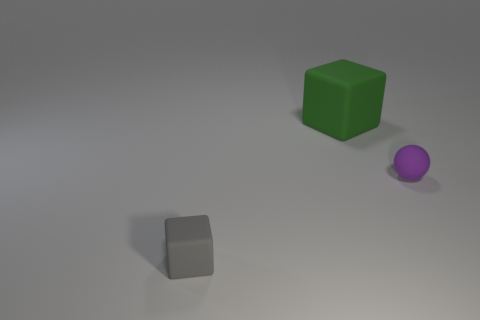Add 1 green objects. How many objects exist? 4 Subtract all spheres. How many objects are left? 2 Subtract all tiny purple rubber objects. Subtract all tiny cyan rubber balls. How many objects are left? 2 Add 3 green rubber objects. How many green rubber objects are left? 4 Add 2 gray things. How many gray things exist? 3 Subtract 0 brown cylinders. How many objects are left? 3 